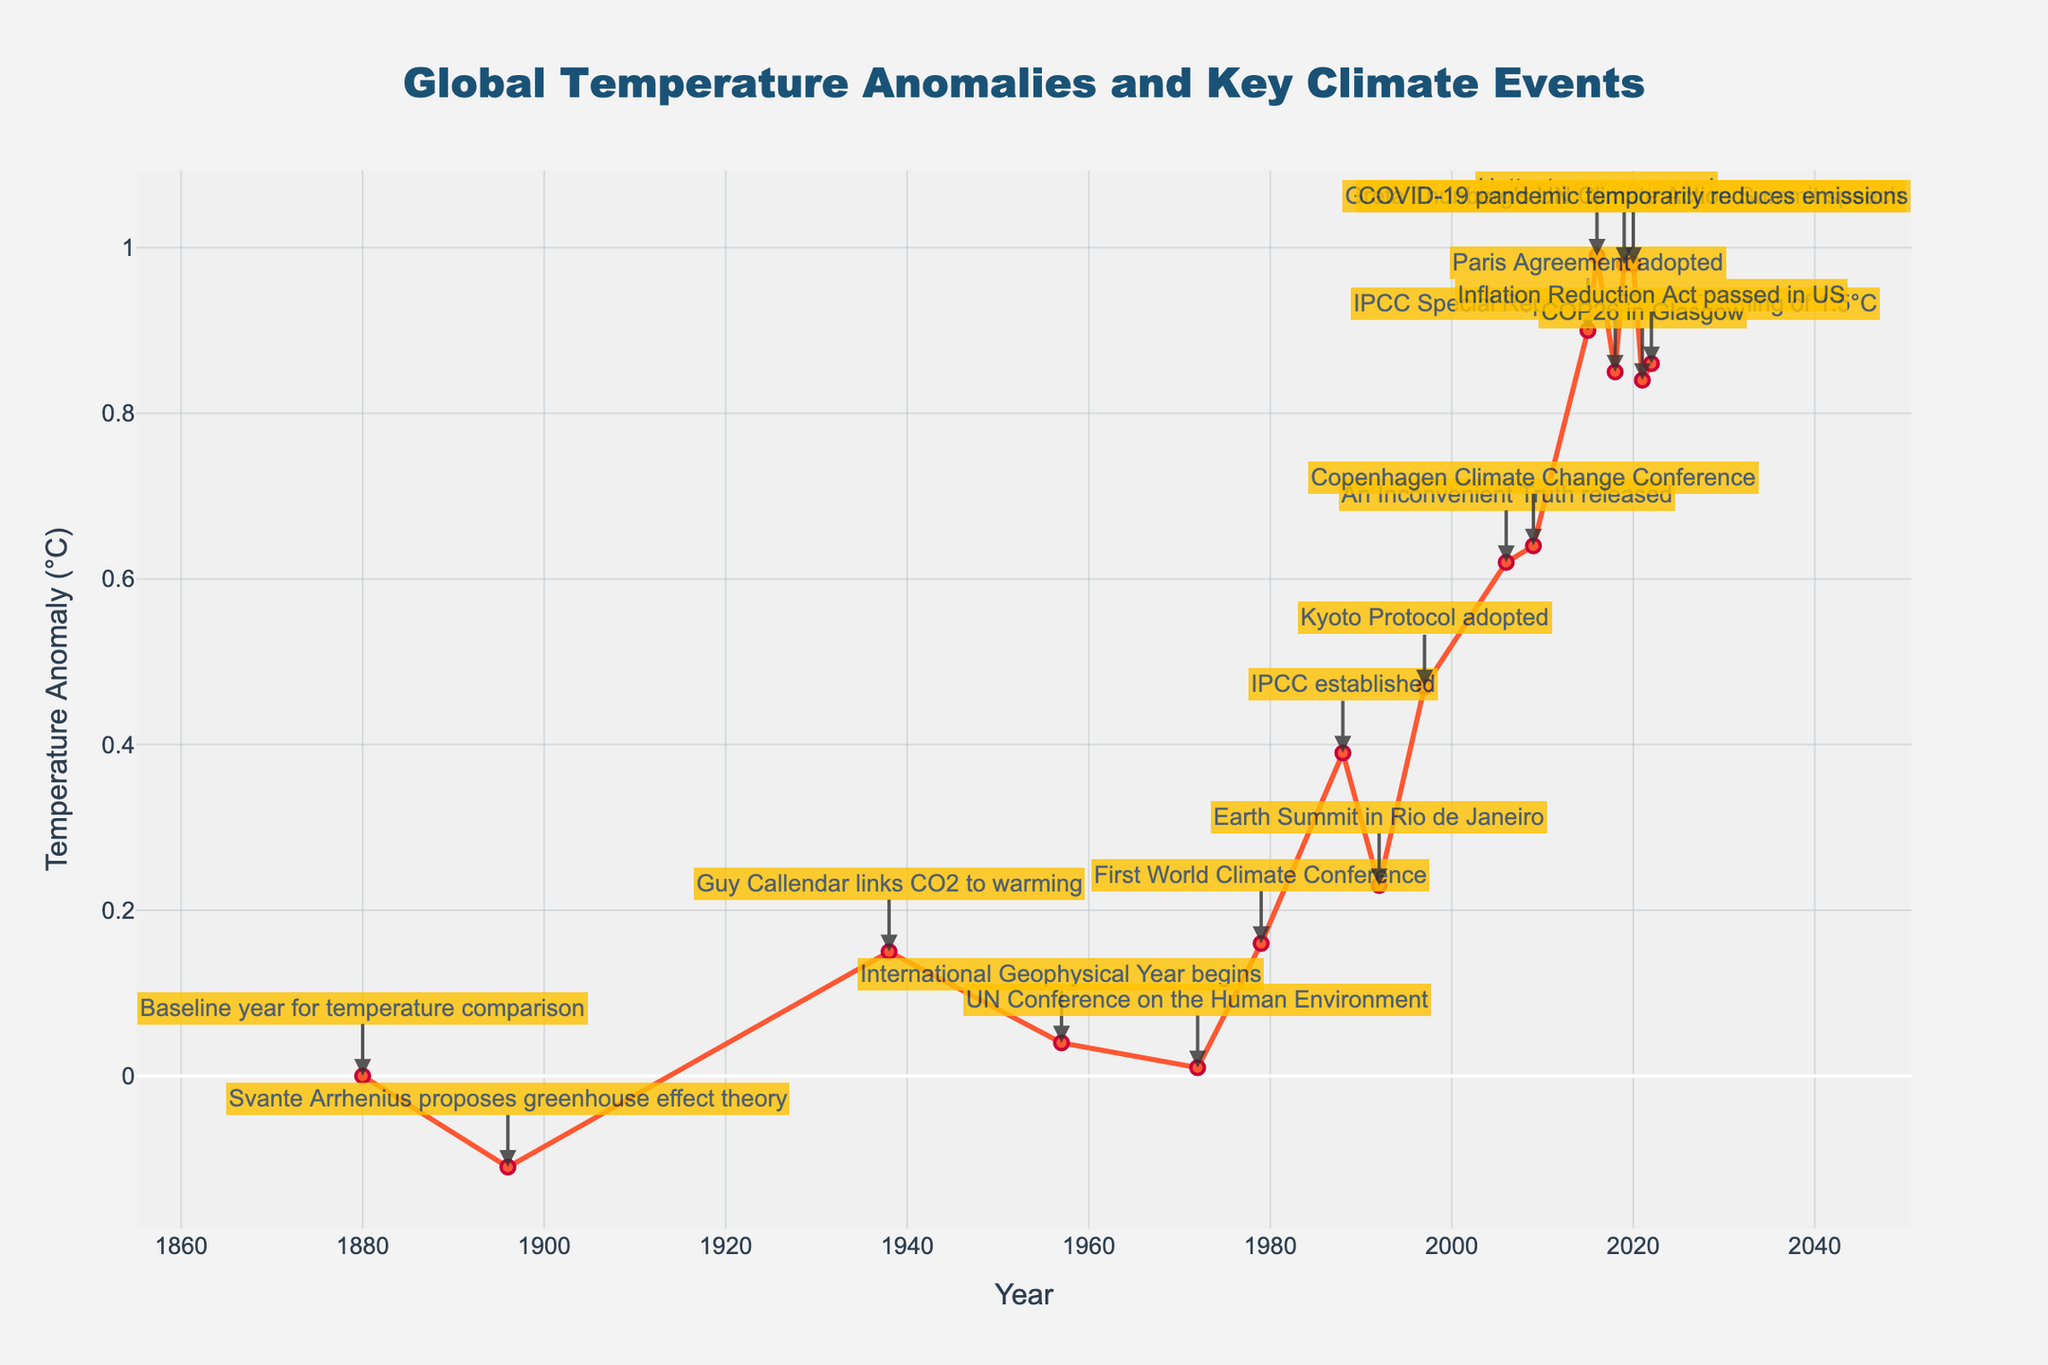What was the Global Temperature Anomaly in 2016? To find the Global Temperature Anomaly in 2016, look at the data point for the year 2016. The anomaly value shown is 0.99°C.
Answer: 0.99°C What is the difference in Global Temperature Anomaly between 1880 and 2015? To calculate the difference, subtract the 1880 anomaly value (0.0°C) from the 2015 anomaly value (0.90°C). 0.90 - 0.0 = 0.90°C.
Answer: 0.90°C How many key climate events are annotated between 1970 and 2000? Identify the annotated events between 1970 and 2000 from the figure: UN Conference on the Human Environment (1972), First World Climate Conference (1979), IPCC established (1988), Earth Summit in Rio de Janeiro (1992), and Kyoto Protocol adopted (1997). Count these events.
Answer: 5 Compare the Global Temperature Anomalies in 1990 and 2020. Which year had a higher anomaly? Check the figure for anomaly values in 1990 (0.39°C) and 2020 (0.98°C). The 2020 anomaly is higher.
Answer: 2020 By how much did the Global Temperature Anomaly increase between the release of "An Inconvenient Truth" (2006) and the Paris Agreement (2015)? Locate the anomaly values for 2006 (0.62°C) and 2015 (0.90°C). Subtract the 2006 value from the 2015 value: 0.90 - 0.62 = 0.28°C.
Answer: 0.28°C What is the trend in Global Temperature Anomaly from 1880 to 2022? Observe the general direction of the temperature anomaly line. It consistently trends upward from 0.0°C in 1880 to a higher value of 0.86°C in 2022.
Answer: Upward Between which two successive decades was the largest increase in Global Temperature Anomaly observed? Compare decade averages or trends. Significant increases are seen post-1980; e.g., between the 1990s and 2000s. The anomaly increased notably between these two decades (0.23°C in 1992, 0.62°C in 2006). This comparing step-by-step through each decade is necessary.
Answer: 1990s to 2000s How many years had an anomaly higher than 0.5°C? Review the figure and count all years where the anomaly exceeds 0.5°C. The years 1997, 2006, 2009, 2015, 2016, 2018, 2019, 2020, 2021, and 2022 meet this criterion.
Answer: 10 Describe the Global Temperature Anomaly in the year when Greta Thunberg gave her speech at the UN Climate Action Summit. Find the year of Greta Thunberg's speech (2019) and note the Global Temperature Anomaly for that year, which is 0.98°C.
Answer: 0.98°C 